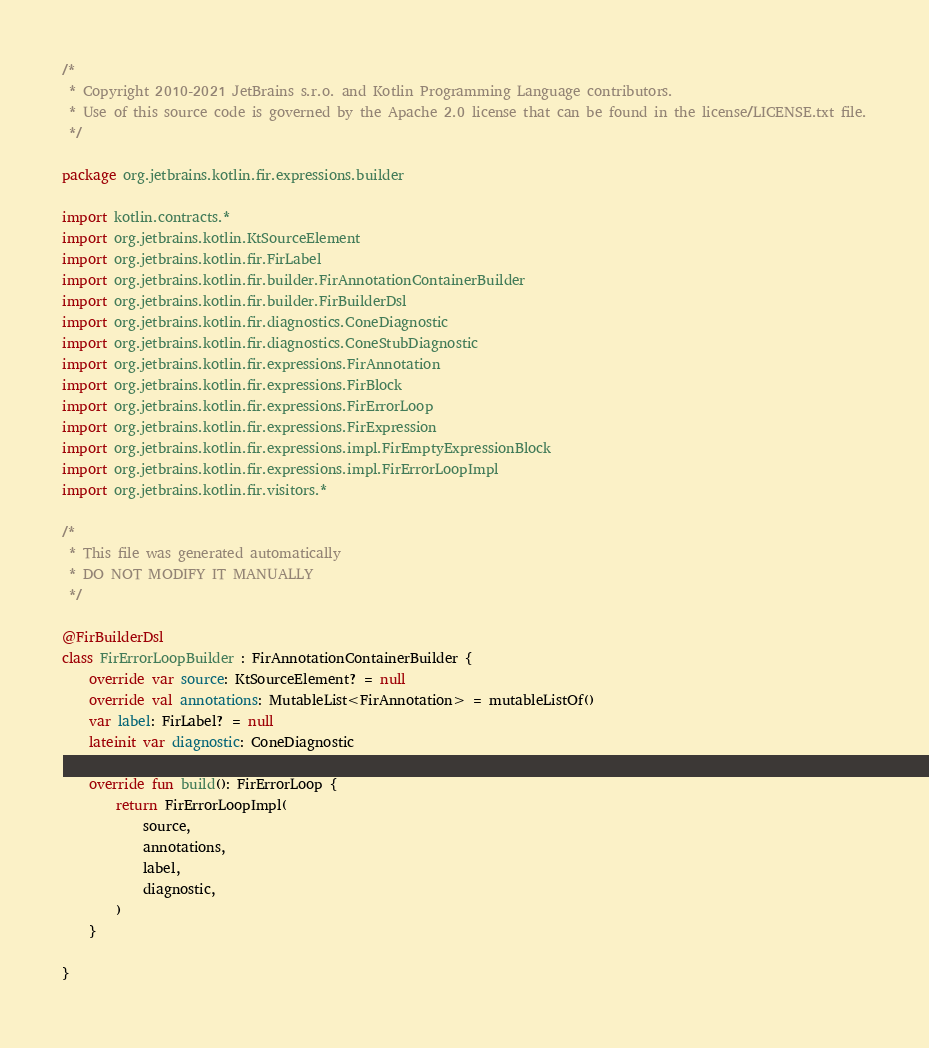<code> <loc_0><loc_0><loc_500><loc_500><_Kotlin_>/*
 * Copyright 2010-2021 JetBrains s.r.o. and Kotlin Programming Language contributors.
 * Use of this source code is governed by the Apache 2.0 license that can be found in the license/LICENSE.txt file.
 */

package org.jetbrains.kotlin.fir.expressions.builder

import kotlin.contracts.*
import org.jetbrains.kotlin.KtSourceElement
import org.jetbrains.kotlin.fir.FirLabel
import org.jetbrains.kotlin.fir.builder.FirAnnotationContainerBuilder
import org.jetbrains.kotlin.fir.builder.FirBuilderDsl
import org.jetbrains.kotlin.fir.diagnostics.ConeDiagnostic
import org.jetbrains.kotlin.fir.diagnostics.ConeStubDiagnostic
import org.jetbrains.kotlin.fir.expressions.FirAnnotation
import org.jetbrains.kotlin.fir.expressions.FirBlock
import org.jetbrains.kotlin.fir.expressions.FirErrorLoop
import org.jetbrains.kotlin.fir.expressions.FirExpression
import org.jetbrains.kotlin.fir.expressions.impl.FirEmptyExpressionBlock
import org.jetbrains.kotlin.fir.expressions.impl.FirErrorLoopImpl
import org.jetbrains.kotlin.fir.visitors.*

/*
 * This file was generated automatically
 * DO NOT MODIFY IT MANUALLY
 */

@FirBuilderDsl
class FirErrorLoopBuilder : FirAnnotationContainerBuilder {
    override var source: KtSourceElement? = null
    override val annotations: MutableList<FirAnnotation> = mutableListOf()
    var label: FirLabel? = null
    lateinit var diagnostic: ConeDiagnostic

    override fun build(): FirErrorLoop {
        return FirErrorLoopImpl(
            source,
            annotations,
            label,
            diagnostic,
        )
    }

}
</code> 